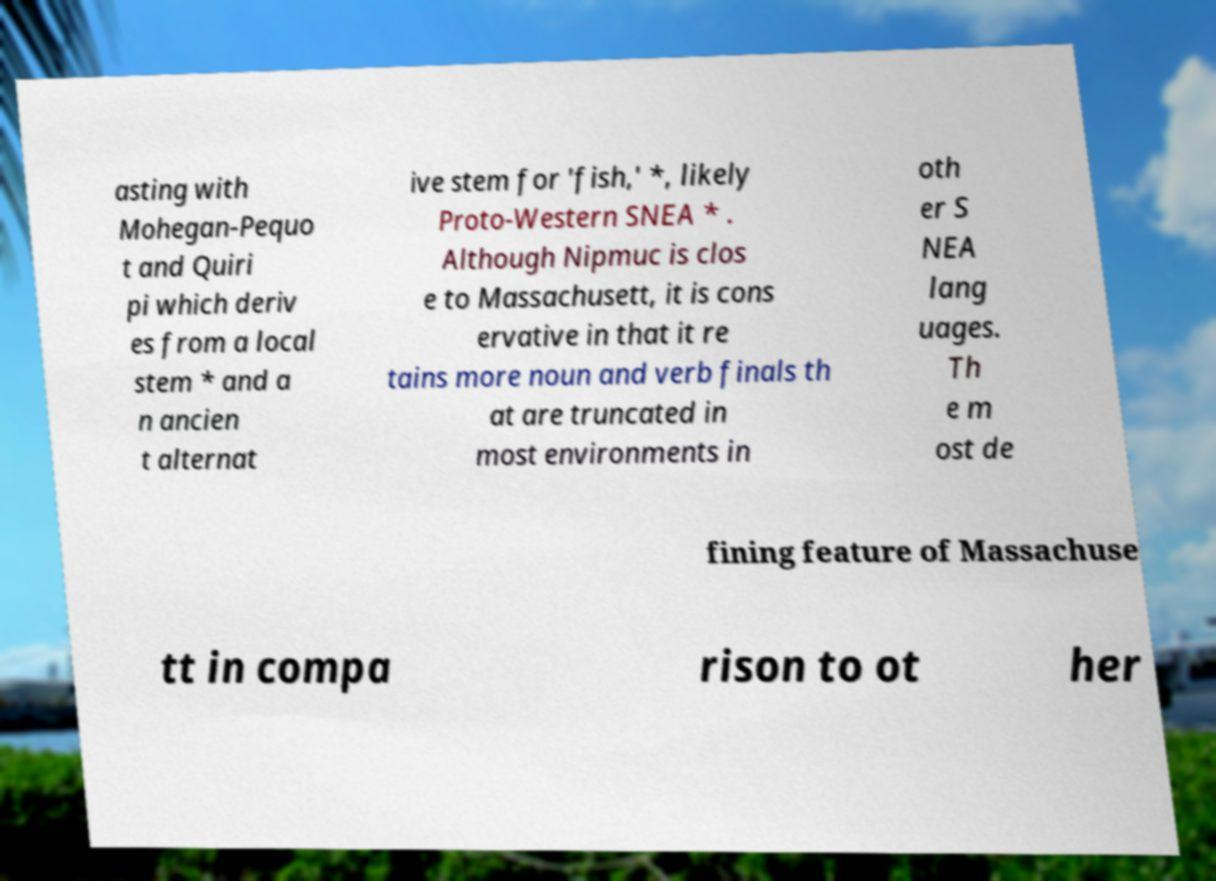I need the written content from this picture converted into text. Can you do that? asting with Mohegan-Pequo t and Quiri pi which deriv es from a local stem * and a n ancien t alternat ive stem for 'fish,' *, likely Proto-Western SNEA * . Although Nipmuc is clos e to Massachusett, it is cons ervative in that it re tains more noun and verb finals th at are truncated in most environments in oth er S NEA lang uages. Th e m ost de fining feature of Massachuse tt in compa rison to ot her 